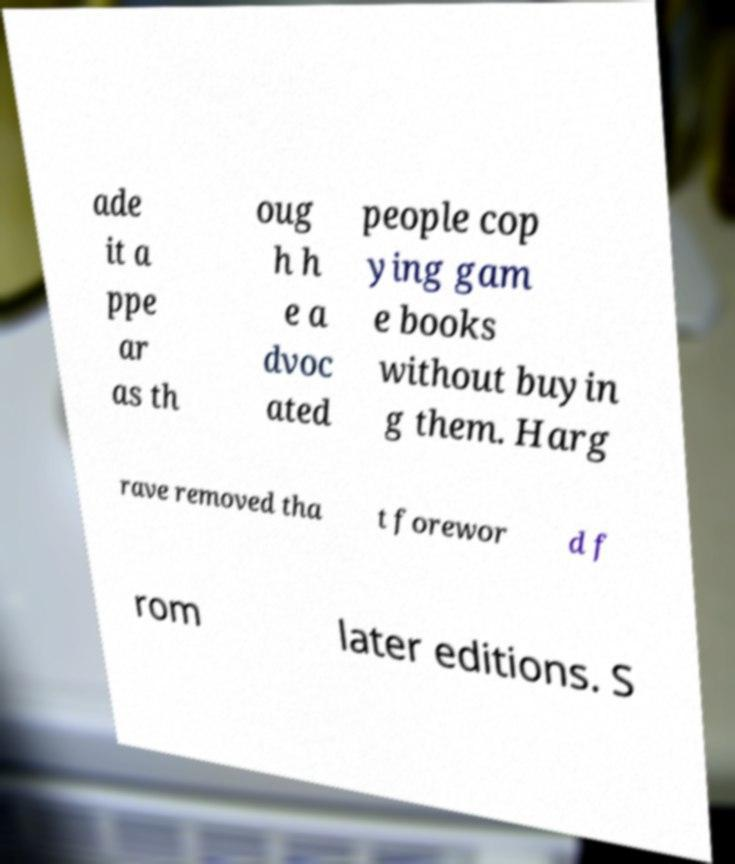There's text embedded in this image that I need extracted. Can you transcribe it verbatim? ade it a ppe ar as th oug h h e a dvoc ated people cop ying gam e books without buyin g them. Harg rave removed tha t forewor d f rom later editions. S 